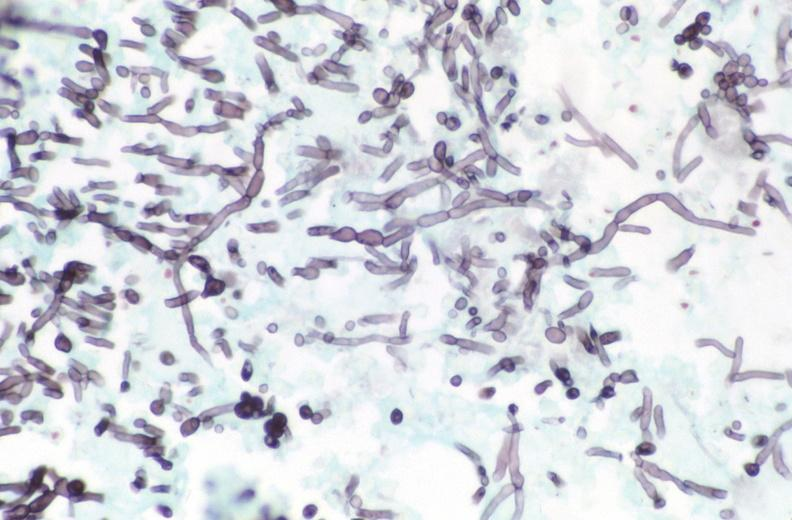do close-up of lesion stain?
Answer the question using a single word or phrase. No 